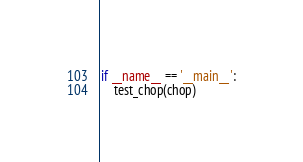<code> <loc_0><loc_0><loc_500><loc_500><_Python_>if __name__ == '__main__':
    test_chop(chop)

</code> 